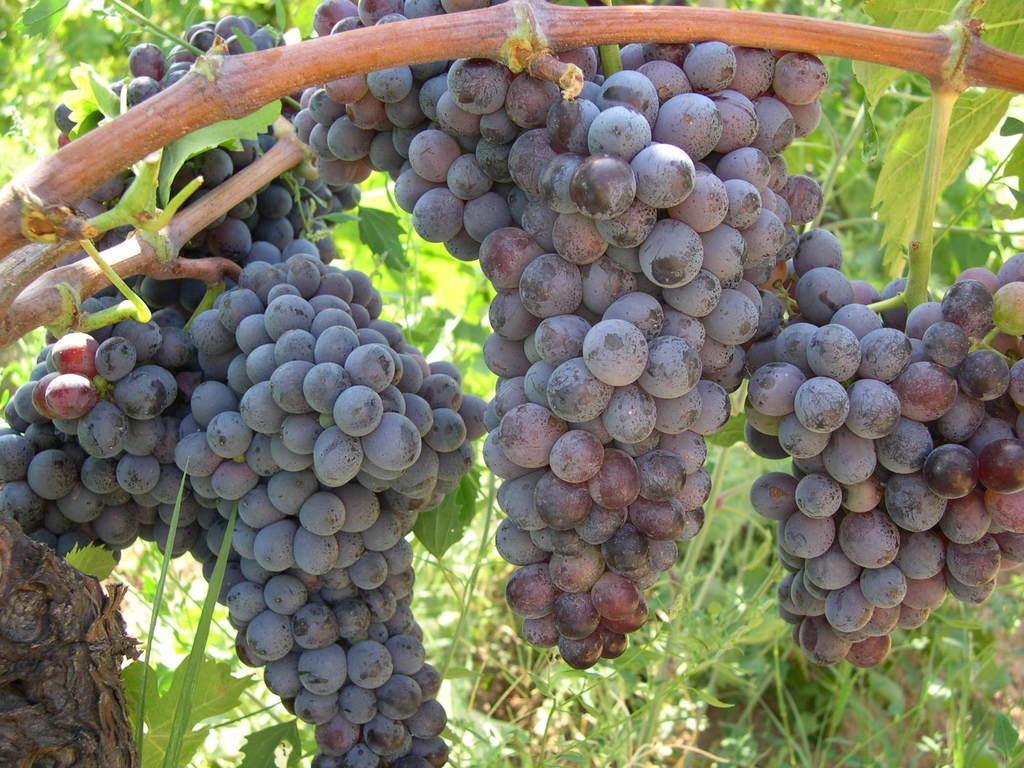What type of fruit can be seen in the image? There are bunches of grapes in the image. Where are the grapes located? The grapes are hanging on a tree. What other types of vegetation are present in the image? There are plants present in the image. How much salt is sprinkled on the grapes in the image? There is no salt present in the image; the grapes are hanging on a tree. What type of heat source is used to ripen the grapes in the image? There is no heat source visible in the image; the grapes are hanging on a tree and ripening naturally. 